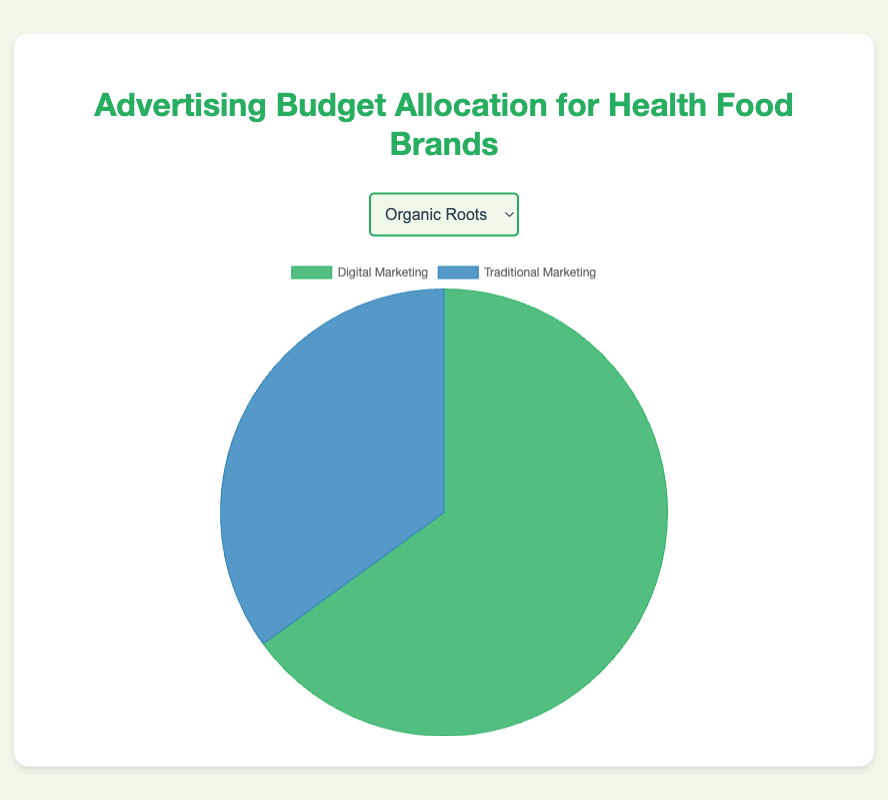Which brand allocates the highest percentage to digital marketing? Looking at the digital marketing percentages, the brand with the highest allocation is Vitality Foods with 75%.
Answer: Vitality Foods Which brand allocates more to traditional marketing than digital marketing? Comparing the traditional and digital marketing allocations, only Nature's Best allocates more to traditional marketing, with 45% for traditional vs. 55% for digital.
Answer: Nature's Best What's the average digital marketing percentage across all brands? Sum the digital marketing percentages (65 + 70 + 55 + 60 + 75) = 325, then divide by the number of brands (5). 325 / 5 = 65.
Answer: 65 Which brand has exactly 40% allocation for traditional marketing? By reviewing the traditional marketing allocations, Health Harvest allocates exactly 40%.
Answer: Health Harvest Compare the digital marketing percentages of Purely Green and Health Harvest. Which brand has a higher percentage? Purely Green allocates 70% to digital marketing, while Health Harvest allocates 60%. Thus, Purely Green has a higher percentage.
Answer: Purely Green What is the total percentage allocated to digital marketing and traditional marketing for Organic Roots combined? Adding the digital marketing (65%) and traditional marketing (35%) percentages for Organic Roots, we get 65 + 35 = 100%.
Answer: 100% Which brand allocates the lowest percentage to traditional marketing? The brand with the lowest percentage allocation to traditional marketing is Vitality Foods with 25%.
Answer: Vitality Foods Compare the sum of digital marketing percentages for Organic Roots and Vitality Foods. Adding the digital marketing percentages for Organic Roots (65%) and Vitality Foods (75%), we get 65 + 75 = 140%.
Answer: 140% What's the difference in digital marketing allocation between the brand with the highest and the brand with the lowest percentage? The highest digital marketing percentage is 75% (Vitality Foods) and the lowest is 55% (Nature's Best). The difference is 75 - 55 = 20%.
Answer: 20% Based on the colors, which part of Nature's Best's pie chart is blue and what does it represent? The blue part of Nature's Best's pie chart represents traditional marketing, which is 45%.
Answer: Traditional marketing, 45% 